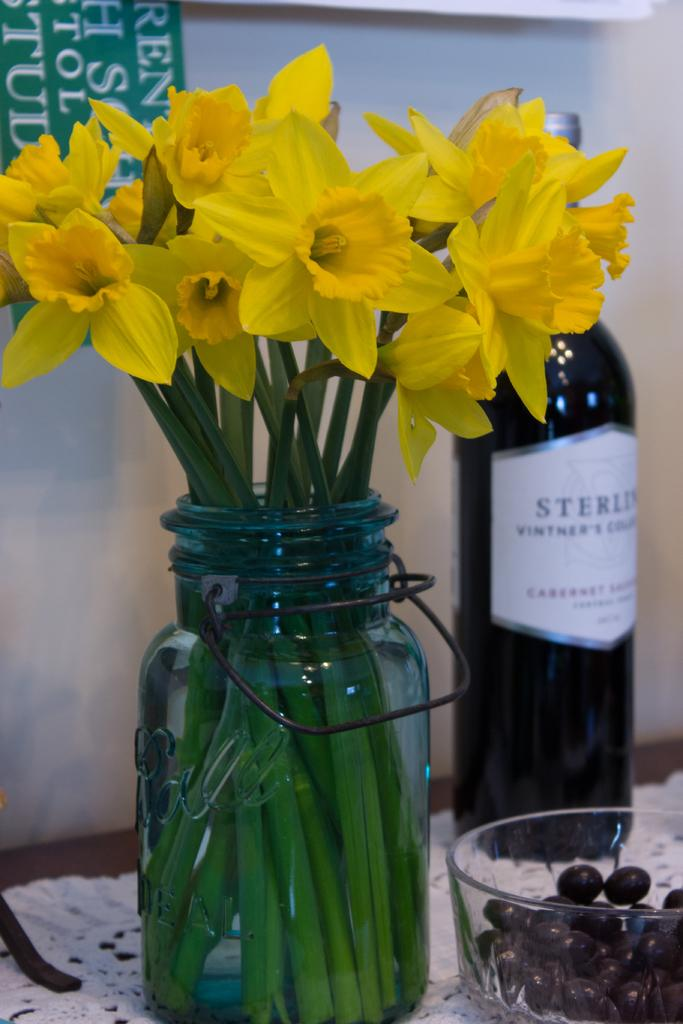What is located at the bottom of the image? There is a table at the bottom of the image. What objects can be seen on the table? There is a bottle, a bowl, a flower vase, and a cloth on the table. What is the background of the image? There is a wall in the background of the image. How many nails are holding the table together in the image? There is no information about nails in the image, as it only shows the table and objects on it. 